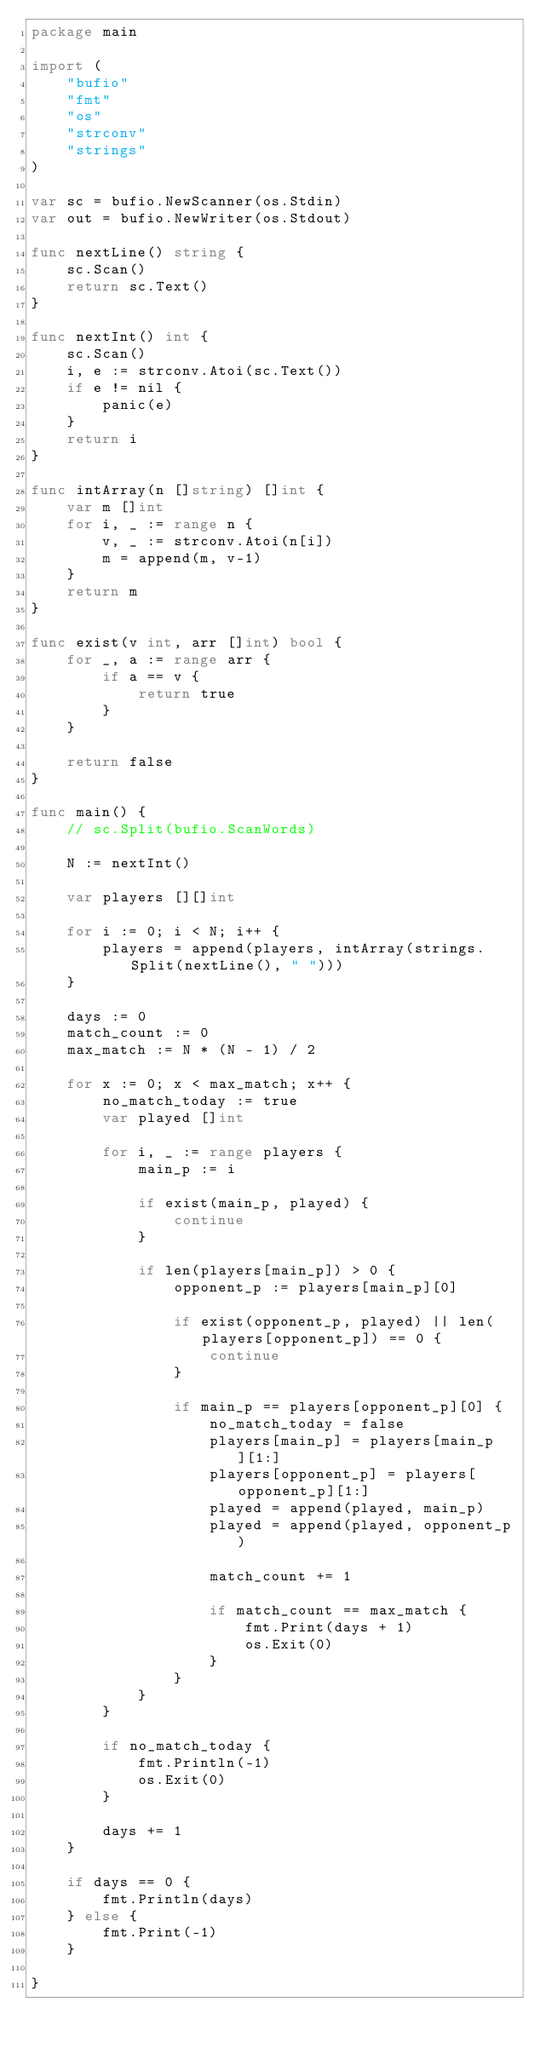<code> <loc_0><loc_0><loc_500><loc_500><_Go_>package main

import (
	"bufio"
	"fmt"
	"os"
	"strconv"
	"strings"
)

var sc = bufio.NewScanner(os.Stdin)
var out = bufio.NewWriter(os.Stdout)

func nextLine() string {
	sc.Scan()
	return sc.Text()
}

func nextInt() int {
	sc.Scan()
	i, e := strconv.Atoi(sc.Text())
	if e != nil {
		panic(e)
	}
	return i
}

func intArray(n []string) []int {
	var m []int
	for i, _ := range n {
		v, _ := strconv.Atoi(n[i])
		m = append(m, v-1)
	}
	return m
}

func exist(v int, arr []int) bool {
	for _, a := range arr {
		if a == v {
			return true
		}
	}

	return false
}

func main() {
	// sc.Split(bufio.ScanWords)

	N := nextInt()

	var players [][]int

	for i := 0; i < N; i++ {
		players = append(players, intArray(strings.Split(nextLine(), " ")))
	}

	days := 0
	match_count := 0
	max_match := N * (N - 1) / 2

	for x := 0; x < max_match; x++ {
		no_match_today := true
		var played []int

		for i, _ := range players {
			main_p := i

			if exist(main_p, played) {
				continue
			}

			if len(players[main_p]) > 0 {
				opponent_p := players[main_p][0]

				if exist(opponent_p, played) || len(players[opponent_p]) == 0 {
					continue
				}

				if main_p == players[opponent_p][0] {
					no_match_today = false
					players[main_p] = players[main_p][1:]
					players[opponent_p] = players[opponent_p][1:]
					played = append(played, main_p)
					played = append(played, opponent_p)

					match_count += 1

					if match_count == max_match {
						fmt.Print(days + 1)
						os.Exit(0)
					}
				}
			}
		}

		if no_match_today {
			fmt.Println(-1)
			os.Exit(0)
		}

		days += 1
	}

	if days == 0 {
		fmt.Println(days)
	} else {
		fmt.Print(-1)
	}

}
</code> 